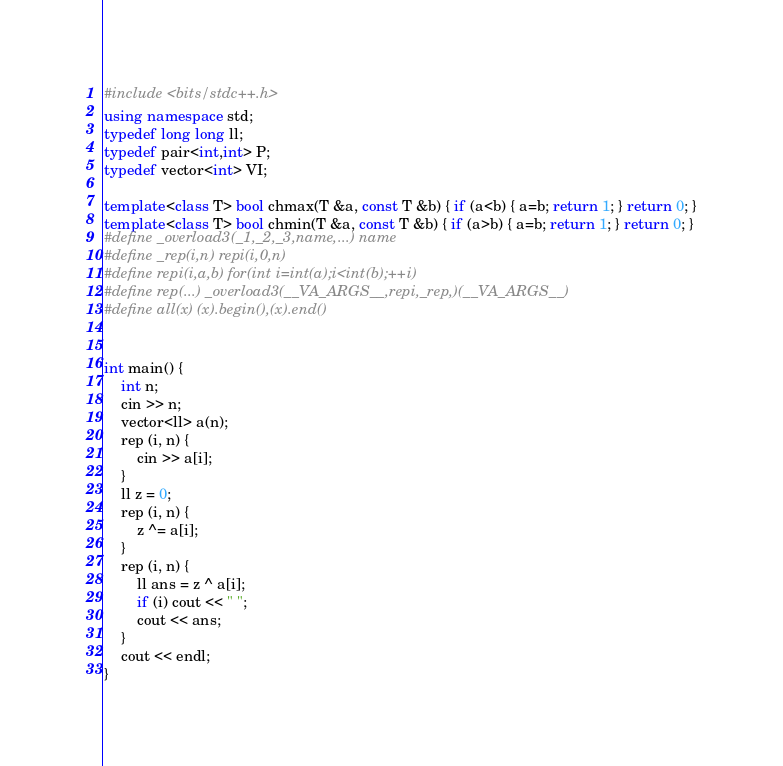Convert code to text. <code><loc_0><loc_0><loc_500><loc_500><_C++_>#include <bits/stdc++.h>
using namespace std;
typedef long long ll;
typedef pair<int,int> P;
typedef vector<int> VI;

template<class T> bool chmax(T &a, const T &b) { if (a<b) { a=b; return 1; } return 0; }
template<class T> bool chmin(T &a, const T &b) { if (a>b) { a=b; return 1; } return 0; }
#define _overload3(_1,_2,_3,name,...) name
#define _rep(i,n) repi(i,0,n)
#define repi(i,a,b) for(int i=int(a);i<int(b);++i)
#define rep(...) _overload3(__VA_ARGS__,repi,_rep,)(__VA_ARGS__)
#define all(x) (x).begin(),(x).end()


int main() {
    int n;
    cin >> n;
    vector<ll> a(n);
    rep (i, n) {
        cin >> a[i];
    }
    ll z = 0;
    rep (i, n) {
        z ^= a[i];
    }
    rep (i, n) {
        ll ans = z ^ a[i];
        if (i) cout << " ";
        cout << ans;
    }
    cout << endl;
}


</code> 